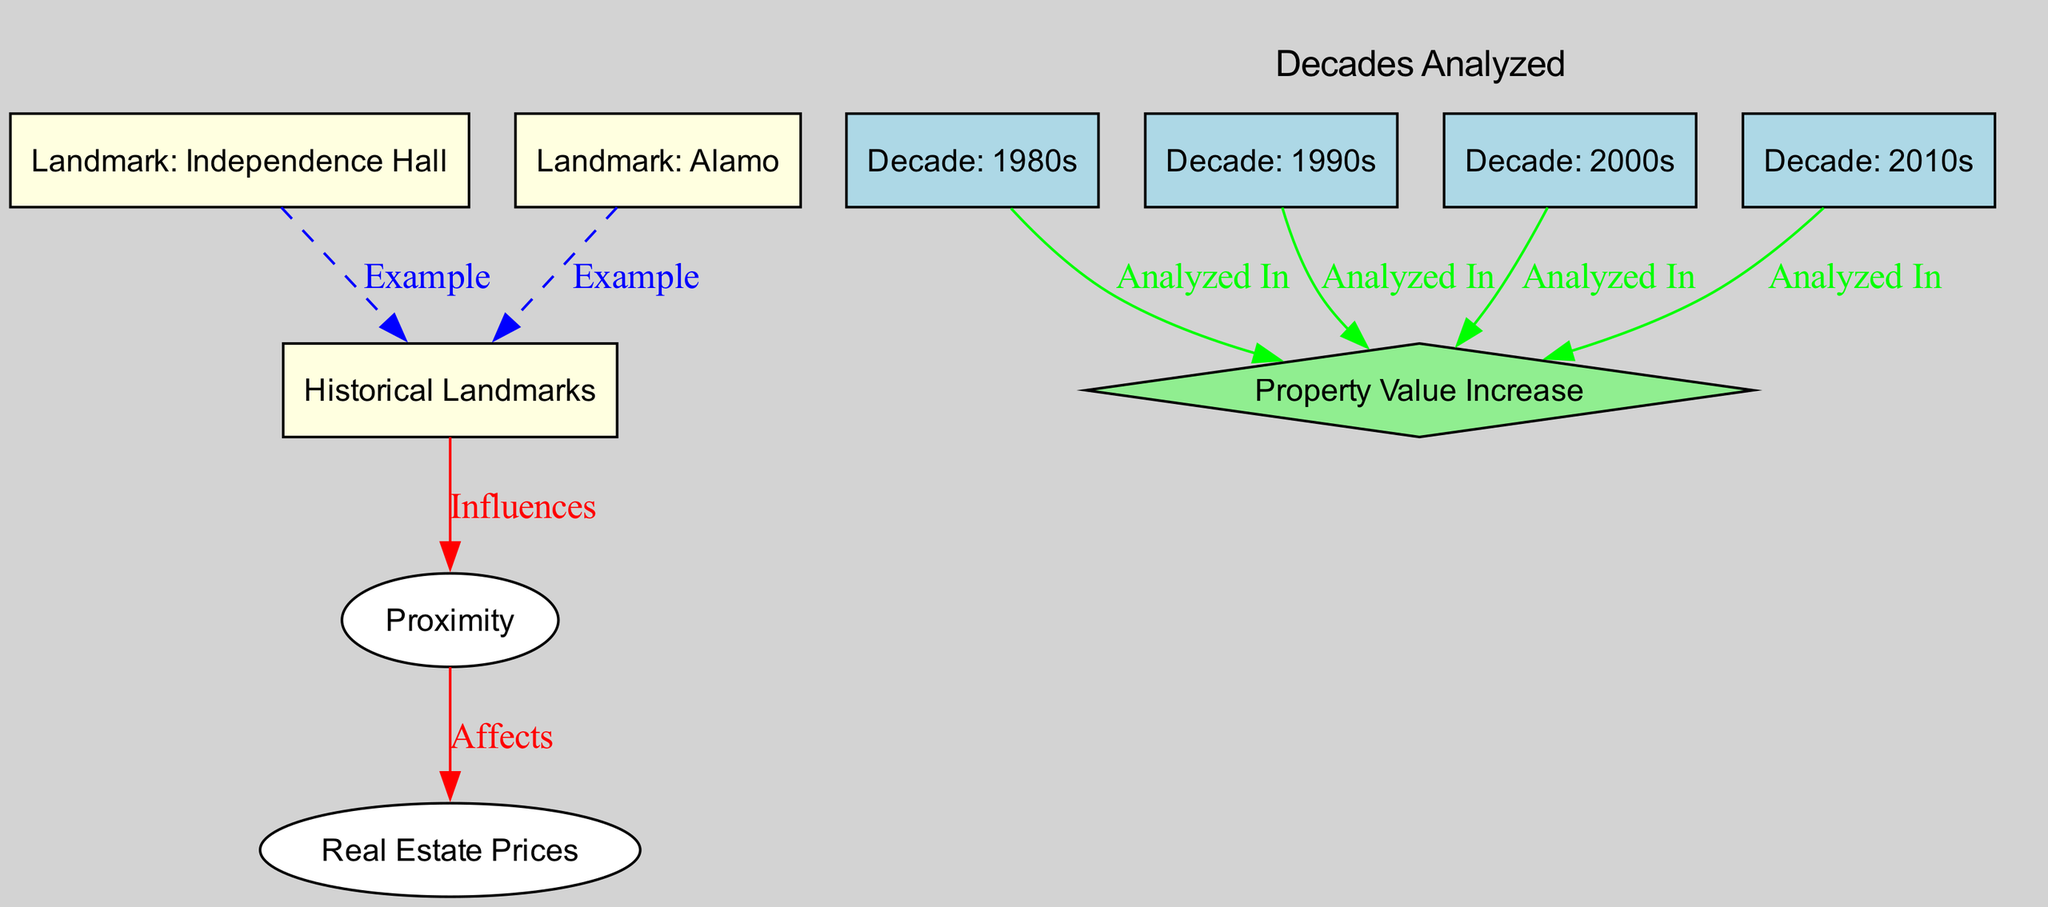what are the examples of historical landmarks shown in the diagram? The diagram includes "Independence Hall" and "Alamo" as examples of historical landmarks, indicated by the edges connecting them to the "Historical Landmarks" node.
Answer: Independence Hall, Alamo how many decades are analyzed in the diagram? The diagram lists four decades: the 1980s, 1990s, 2000s, and 2010s, which can be counted from the nodes representing each decade.
Answer: 4 what is the color that represents historical landmarks in the diagram? Historical landmarks are represented in light yellow according to the node style defined in the diagram, which is specified for landmarks.
Answer: light yellow which nodes influence real estate prices? The "Proximity" node is the only one that influences "Real Estate Prices," as indicated by the directed edge labeled "Affects" from "Proximity" to "Real Estate Prices."
Answer: Proximity which decade shows an analysis related to property value increase? All four decades (1980s, 1990s, 2000s, and 2010s) show an analysis related to property value increase, as each decade node has an edge labeled "Analyzed In" connecting it to "Property Value Increase."
Answer: 1980s, 1990s, 2000s, 2010s which landmark does the diagram provide an example of? The diagram provides examples of historical landmarks, specifically "Independence Hall" and "Alamo," as indicated by edges that connect these to the "Historical Landmarks" node.
Answer: Independence Hall, Alamo how many relationships are depicted in the diagram? The diagram shows a total of six relationships (edges) outlined between the different nodes, considering all the connections.
Answer: 6 what is the shape of the 'Property Value Increase' node in the diagram? The shape of the 'Property Value Increase' node is a diamond, which is distinct from the other nodes and is used to represent key outcomes in the analysis.
Answer: diamond 